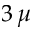<formula> <loc_0><loc_0><loc_500><loc_500>3 \, \mu</formula> 